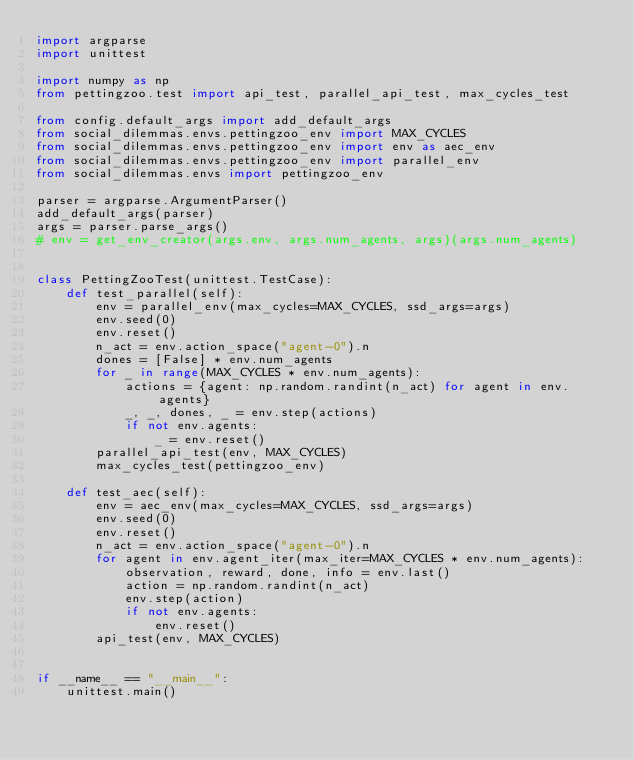Convert code to text. <code><loc_0><loc_0><loc_500><loc_500><_Python_>import argparse
import unittest

import numpy as np
from pettingzoo.test import api_test, parallel_api_test, max_cycles_test

from config.default_args import add_default_args
from social_dilemmas.envs.pettingzoo_env import MAX_CYCLES
from social_dilemmas.envs.pettingzoo_env import env as aec_env
from social_dilemmas.envs.pettingzoo_env import parallel_env
from social_dilemmas.envs import pettingzoo_env

parser = argparse.ArgumentParser()
add_default_args(parser)
args = parser.parse_args()
# env = get_env_creator(args.env, args.num_agents, args)(args.num_agents)


class PettingZooTest(unittest.TestCase):
    def test_parallel(self):
        env = parallel_env(max_cycles=MAX_CYCLES, ssd_args=args)
        env.seed(0)
        env.reset()
        n_act = env.action_space("agent-0").n
        dones = [False] * env.num_agents
        for _ in range(MAX_CYCLES * env.num_agents):
            actions = {agent: np.random.randint(n_act) for agent in env.agents}
            _, _, dones, _ = env.step(actions)
            if not env.agents:
                _ = env.reset()
        parallel_api_test(env, MAX_CYCLES)
        max_cycles_test(pettingzoo_env)

    def test_aec(self):
        env = aec_env(max_cycles=MAX_CYCLES, ssd_args=args)
        env.seed(0)
        env.reset()
        n_act = env.action_space("agent-0").n
        for agent in env.agent_iter(max_iter=MAX_CYCLES * env.num_agents):
            observation, reward, done, info = env.last()
            action = np.random.randint(n_act)
            env.step(action)
            if not env.agents:
                env.reset()
        api_test(env, MAX_CYCLES)


if __name__ == "__main__":
    unittest.main()
</code> 